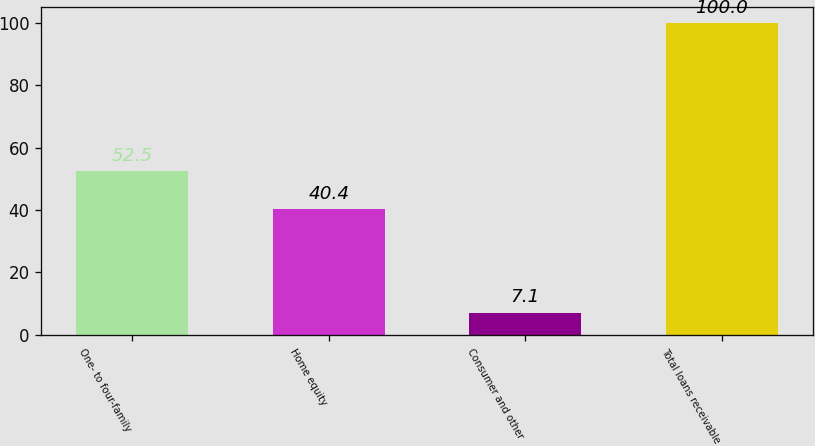Convert chart. <chart><loc_0><loc_0><loc_500><loc_500><bar_chart><fcel>One- to four-family<fcel>Home equity<fcel>Consumer and other<fcel>Total loans receivable<nl><fcel>52.5<fcel>40.4<fcel>7.1<fcel>100<nl></chart> 